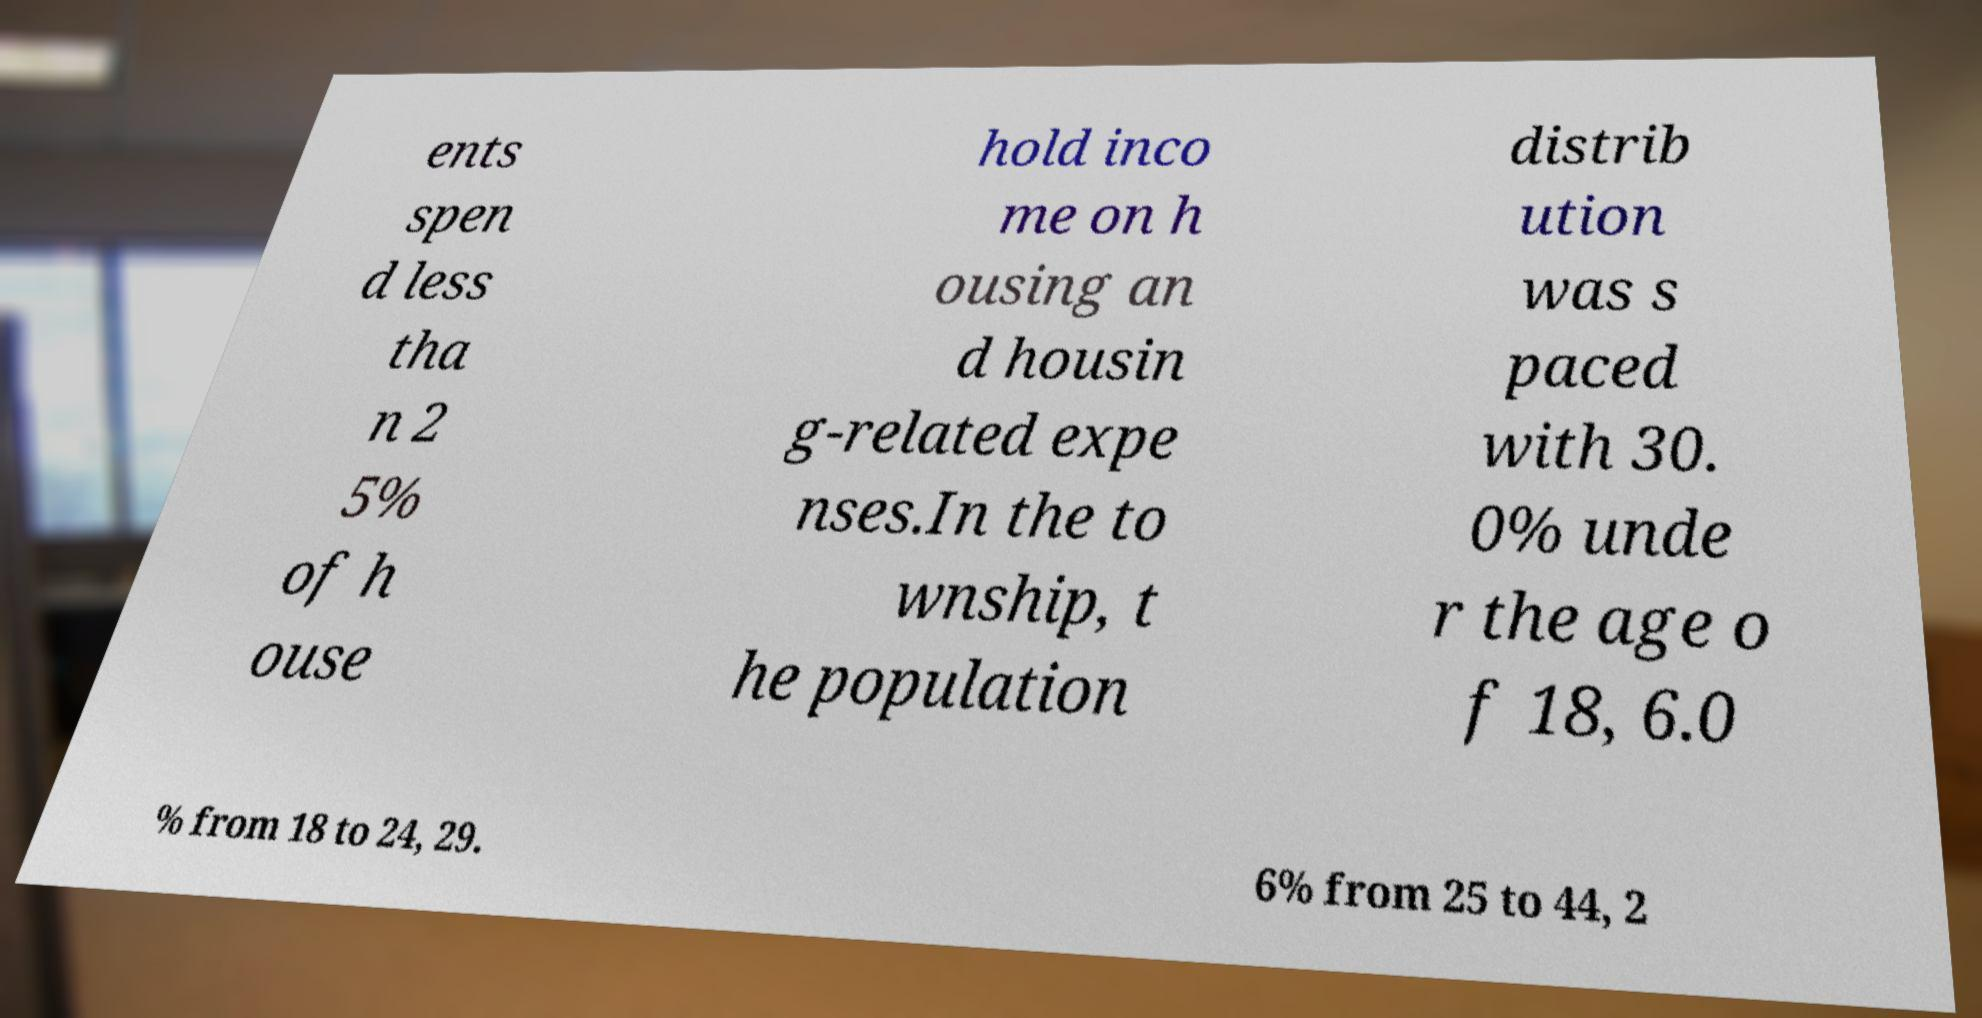For documentation purposes, I need the text within this image transcribed. Could you provide that? ents spen d less tha n 2 5% of h ouse hold inco me on h ousing an d housin g-related expe nses.In the to wnship, t he population distrib ution was s paced with 30. 0% unde r the age o f 18, 6.0 % from 18 to 24, 29. 6% from 25 to 44, 2 